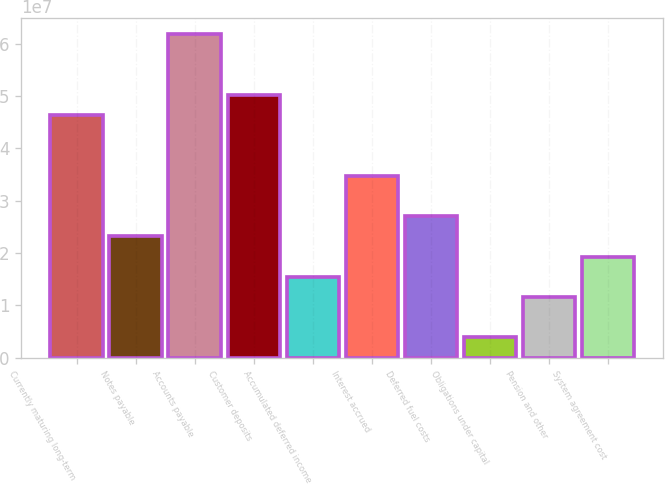Convert chart to OTSL. <chart><loc_0><loc_0><loc_500><loc_500><bar_chart><fcel>Currently maturing long-term<fcel>Notes payable<fcel>Accounts payable<fcel>Customer deposits<fcel>Accumulated deferred income<fcel>Interest accrued<fcel>Deferred fuel costs<fcel>Obligations under capital<fcel>Pension and other<fcel>System agreement cost<nl><fcel>4.64218e+07<fcel>2.32122e+07<fcel>6.18949e+07<fcel>5.02901e+07<fcel>1.54756e+07<fcel>3.4817e+07<fcel>2.70805e+07<fcel>3.87082e+06<fcel>1.16074e+07<fcel>1.93439e+07<nl></chart> 